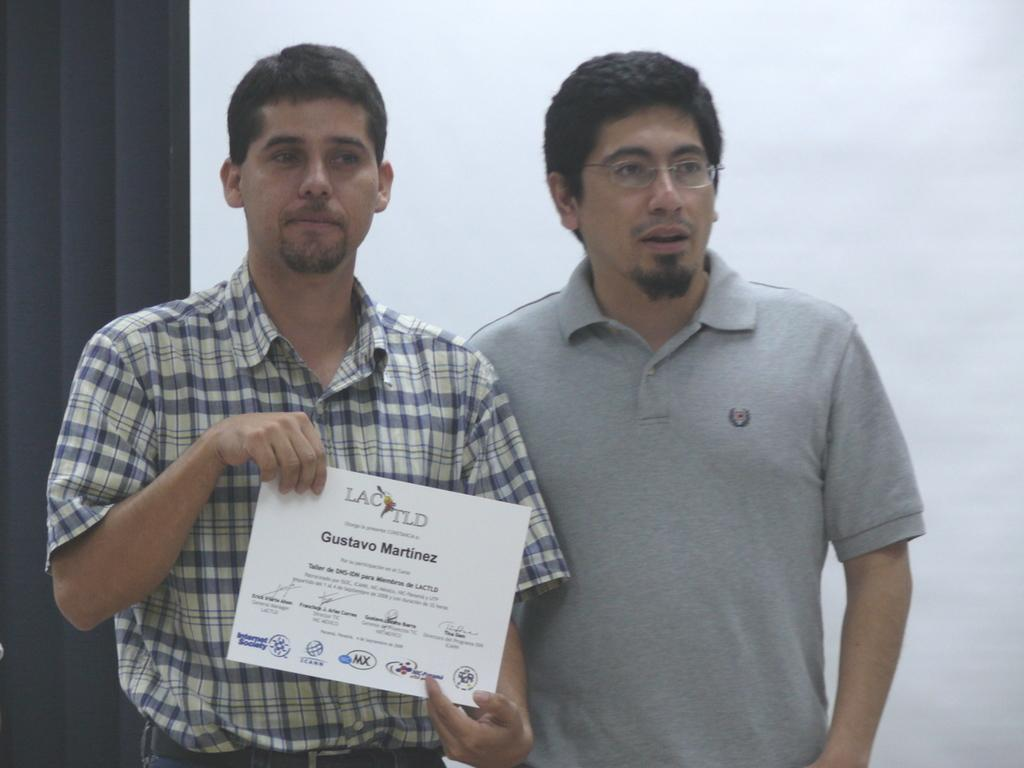How many people are present in the image? There are two people in the image. What is one of the people holding? One person is holding some cards. Can you describe the background of the image? The background of the image is white and black. What type of mailbox can be seen in the image? There is no mailbox present in the image. What is the desire of the person holding the cards in the image? The image does not provide information about the desires of the person holding the cards. 